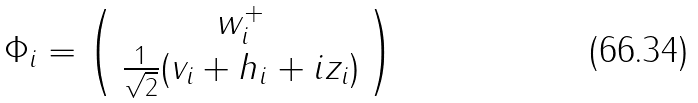<formula> <loc_0><loc_0><loc_500><loc_500>\Phi _ { i } = \left ( \begin{array} { c c } w _ { i } ^ { + } \\ \frac { 1 } { \sqrt { 2 } } ( v _ { i } + h _ { i } + i z _ { i } ) \end{array} \right )</formula> 